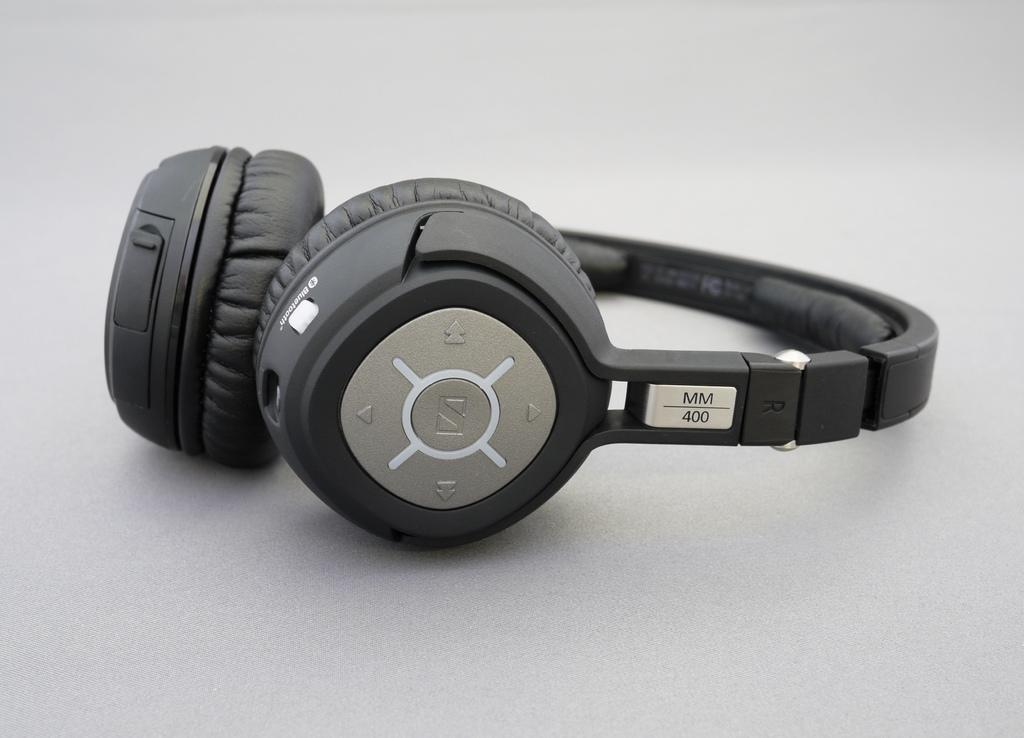What is present in the image that is used for listening to audio? There are headphones in the image that are used for listening to audio. Where are the headphones located in the image? The headphones are on a surface in the image. What feature do the headphones have that allows for control or adjustment? The headphones have buttons in the image. What type of branch can be seen growing out of the headphones in the image? There is no branch present in the image; it only features headphones with buttons on a surface. 